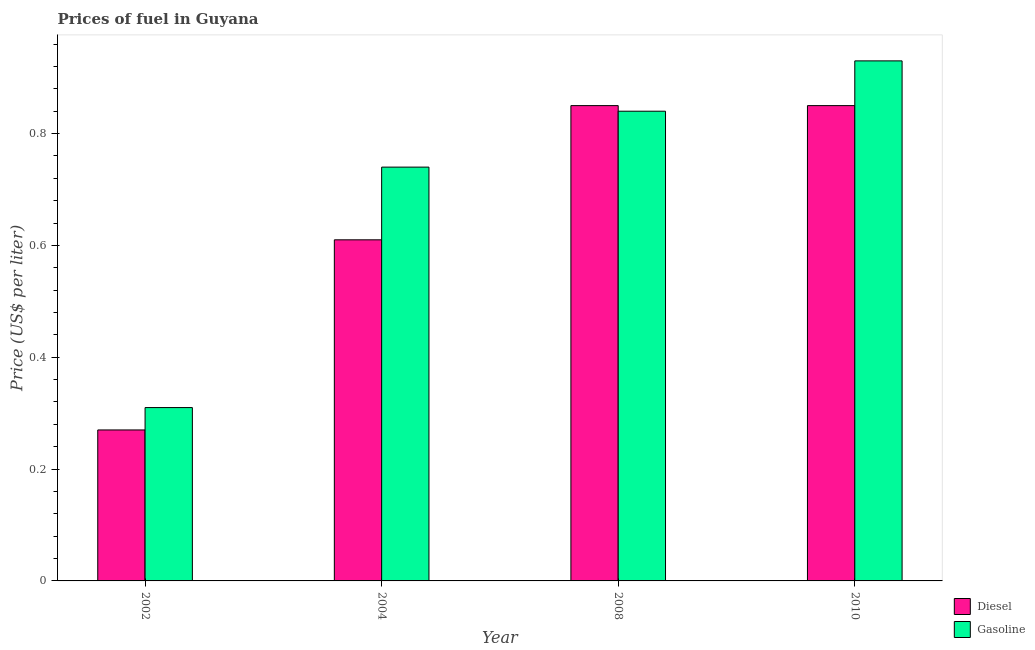How many different coloured bars are there?
Provide a short and direct response. 2. How many groups of bars are there?
Offer a terse response. 4. Are the number of bars per tick equal to the number of legend labels?
Your answer should be very brief. Yes. How many bars are there on the 2nd tick from the left?
Offer a very short reply. 2. In how many cases, is the number of bars for a given year not equal to the number of legend labels?
Your response must be concise. 0. What is the gasoline price in 2002?
Provide a short and direct response. 0.31. Across all years, what is the maximum gasoline price?
Provide a short and direct response. 0.93. Across all years, what is the minimum diesel price?
Make the answer very short. 0.27. In which year was the diesel price maximum?
Give a very brief answer. 2008. In which year was the diesel price minimum?
Your answer should be very brief. 2002. What is the total gasoline price in the graph?
Offer a terse response. 2.82. What is the difference between the gasoline price in 2002 and that in 2004?
Keep it short and to the point. -0.43. What is the difference between the gasoline price in 2010 and the diesel price in 2002?
Provide a succinct answer. 0.62. What is the average gasoline price per year?
Keep it short and to the point. 0.71. What is the ratio of the gasoline price in 2002 to that in 2008?
Your answer should be compact. 0.37. What is the difference between the highest and the second highest gasoline price?
Give a very brief answer. 0.09. What is the difference between the highest and the lowest diesel price?
Provide a short and direct response. 0.58. What does the 2nd bar from the left in 2008 represents?
Ensure brevity in your answer.  Gasoline. What does the 2nd bar from the right in 2002 represents?
Keep it short and to the point. Diesel. How many bars are there?
Your response must be concise. 8. What is the difference between two consecutive major ticks on the Y-axis?
Ensure brevity in your answer.  0.2. Are the values on the major ticks of Y-axis written in scientific E-notation?
Make the answer very short. No. Does the graph contain grids?
Offer a very short reply. No. What is the title of the graph?
Offer a very short reply. Prices of fuel in Guyana. Does "Education" appear as one of the legend labels in the graph?
Ensure brevity in your answer.  No. What is the label or title of the X-axis?
Offer a terse response. Year. What is the label or title of the Y-axis?
Give a very brief answer. Price (US$ per liter). What is the Price (US$ per liter) in Diesel in 2002?
Keep it short and to the point. 0.27. What is the Price (US$ per liter) of Gasoline in 2002?
Offer a terse response. 0.31. What is the Price (US$ per liter) in Diesel in 2004?
Your response must be concise. 0.61. What is the Price (US$ per liter) in Gasoline in 2004?
Offer a very short reply. 0.74. What is the Price (US$ per liter) in Gasoline in 2008?
Make the answer very short. 0.84. What is the Price (US$ per liter) in Diesel in 2010?
Offer a terse response. 0.85. What is the Price (US$ per liter) in Gasoline in 2010?
Offer a very short reply. 0.93. Across all years, what is the maximum Price (US$ per liter) of Gasoline?
Ensure brevity in your answer.  0.93. Across all years, what is the minimum Price (US$ per liter) in Diesel?
Provide a short and direct response. 0.27. Across all years, what is the minimum Price (US$ per liter) of Gasoline?
Provide a succinct answer. 0.31. What is the total Price (US$ per liter) in Diesel in the graph?
Provide a succinct answer. 2.58. What is the total Price (US$ per liter) in Gasoline in the graph?
Offer a terse response. 2.82. What is the difference between the Price (US$ per liter) of Diesel in 2002 and that in 2004?
Your answer should be compact. -0.34. What is the difference between the Price (US$ per liter) in Gasoline in 2002 and that in 2004?
Provide a short and direct response. -0.43. What is the difference between the Price (US$ per liter) of Diesel in 2002 and that in 2008?
Provide a short and direct response. -0.58. What is the difference between the Price (US$ per liter) of Gasoline in 2002 and that in 2008?
Your answer should be very brief. -0.53. What is the difference between the Price (US$ per liter) of Diesel in 2002 and that in 2010?
Your answer should be very brief. -0.58. What is the difference between the Price (US$ per liter) in Gasoline in 2002 and that in 2010?
Provide a succinct answer. -0.62. What is the difference between the Price (US$ per liter) in Diesel in 2004 and that in 2008?
Your response must be concise. -0.24. What is the difference between the Price (US$ per liter) of Gasoline in 2004 and that in 2008?
Keep it short and to the point. -0.1. What is the difference between the Price (US$ per liter) in Diesel in 2004 and that in 2010?
Keep it short and to the point. -0.24. What is the difference between the Price (US$ per liter) in Gasoline in 2004 and that in 2010?
Ensure brevity in your answer.  -0.19. What is the difference between the Price (US$ per liter) in Diesel in 2008 and that in 2010?
Provide a succinct answer. 0. What is the difference between the Price (US$ per liter) in Gasoline in 2008 and that in 2010?
Provide a succinct answer. -0.09. What is the difference between the Price (US$ per liter) in Diesel in 2002 and the Price (US$ per liter) in Gasoline in 2004?
Your answer should be very brief. -0.47. What is the difference between the Price (US$ per liter) in Diesel in 2002 and the Price (US$ per liter) in Gasoline in 2008?
Offer a very short reply. -0.57. What is the difference between the Price (US$ per liter) in Diesel in 2002 and the Price (US$ per liter) in Gasoline in 2010?
Provide a short and direct response. -0.66. What is the difference between the Price (US$ per liter) in Diesel in 2004 and the Price (US$ per liter) in Gasoline in 2008?
Offer a very short reply. -0.23. What is the difference between the Price (US$ per liter) of Diesel in 2004 and the Price (US$ per liter) of Gasoline in 2010?
Provide a short and direct response. -0.32. What is the difference between the Price (US$ per liter) of Diesel in 2008 and the Price (US$ per liter) of Gasoline in 2010?
Make the answer very short. -0.08. What is the average Price (US$ per liter) of Diesel per year?
Offer a terse response. 0.65. What is the average Price (US$ per liter) in Gasoline per year?
Your answer should be very brief. 0.7. In the year 2002, what is the difference between the Price (US$ per liter) of Diesel and Price (US$ per liter) of Gasoline?
Provide a succinct answer. -0.04. In the year 2004, what is the difference between the Price (US$ per liter) in Diesel and Price (US$ per liter) in Gasoline?
Offer a terse response. -0.13. In the year 2010, what is the difference between the Price (US$ per liter) of Diesel and Price (US$ per liter) of Gasoline?
Your response must be concise. -0.08. What is the ratio of the Price (US$ per liter) of Diesel in 2002 to that in 2004?
Offer a very short reply. 0.44. What is the ratio of the Price (US$ per liter) of Gasoline in 2002 to that in 2004?
Your response must be concise. 0.42. What is the ratio of the Price (US$ per liter) in Diesel in 2002 to that in 2008?
Your response must be concise. 0.32. What is the ratio of the Price (US$ per liter) in Gasoline in 2002 to that in 2008?
Offer a terse response. 0.37. What is the ratio of the Price (US$ per liter) in Diesel in 2002 to that in 2010?
Offer a terse response. 0.32. What is the ratio of the Price (US$ per liter) in Diesel in 2004 to that in 2008?
Offer a terse response. 0.72. What is the ratio of the Price (US$ per liter) in Gasoline in 2004 to that in 2008?
Make the answer very short. 0.88. What is the ratio of the Price (US$ per liter) of Diesel in 2004 to that in 2010?
Offer a terse response. 0.72. What is the ratio of the Price (US$ per liter) in Gasoline in 2004 to that in 2010?
Provide a succinct answer. 0.8. What is the ratio of the Price (US$ per liter) of Diesel in 2008 to that in 2010?
Keep it short and to the point. 1. What is the ratio of the Price (US$ per liter) of Gasoline in 2008 to that in 2010?
Provide a short and direct response. 0.9. What is the difference between the highest and the second highest Price (US$ per liter) in Diesel?
Provide a succinct answer. 0. What is the difference between the highest and the second highest Price (US$ per liter) in Gasoline?
Provide a short and direct response. 0.09. What is the difference between the highest and the lowest Price (US$ per liter) in Diesel?
Give a very brief answer. 0.58. What is the difference between the highest and the lowest Price (US$ per liter) of Gasoline?
Offer a terse response. 0.62. 